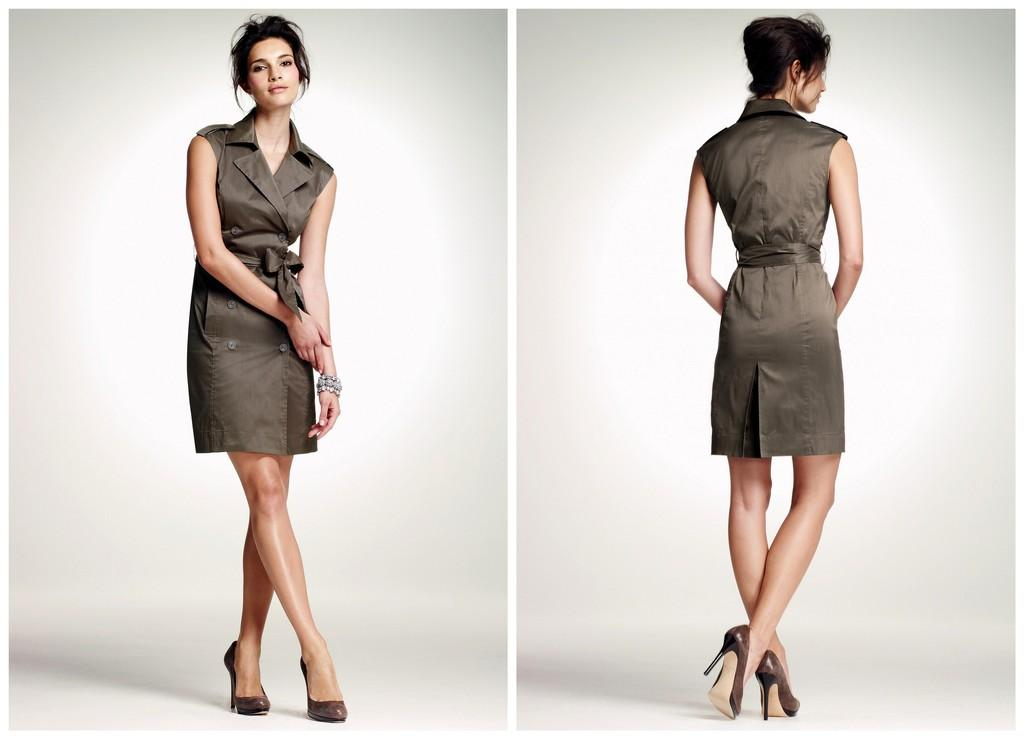What is the composition of the image? The image is a collage of two images. What can be seen on the right side of the image? On the right side of the image, there is a woman standing. What is the woman on the left side of the image doing? On the left side of the image, there is a woman standing and smiling. How many trees are visible in the image? There are no trees visible in the image; it is a collage of two images featuring women standing and smiling. What type of blade is being used by the woman on the left side of the image? There is no blade present in the image; both women are standing and smiling without any tools or objects. 